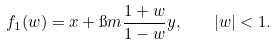Convert formula to latex. <formula><loc_0><loc_0><loc_500><loc_500>f _ { 1 } ( w ) = x + \i m \frac { 1 + w } { 1 - w } y , \quad | w | < 1 .</formula> 